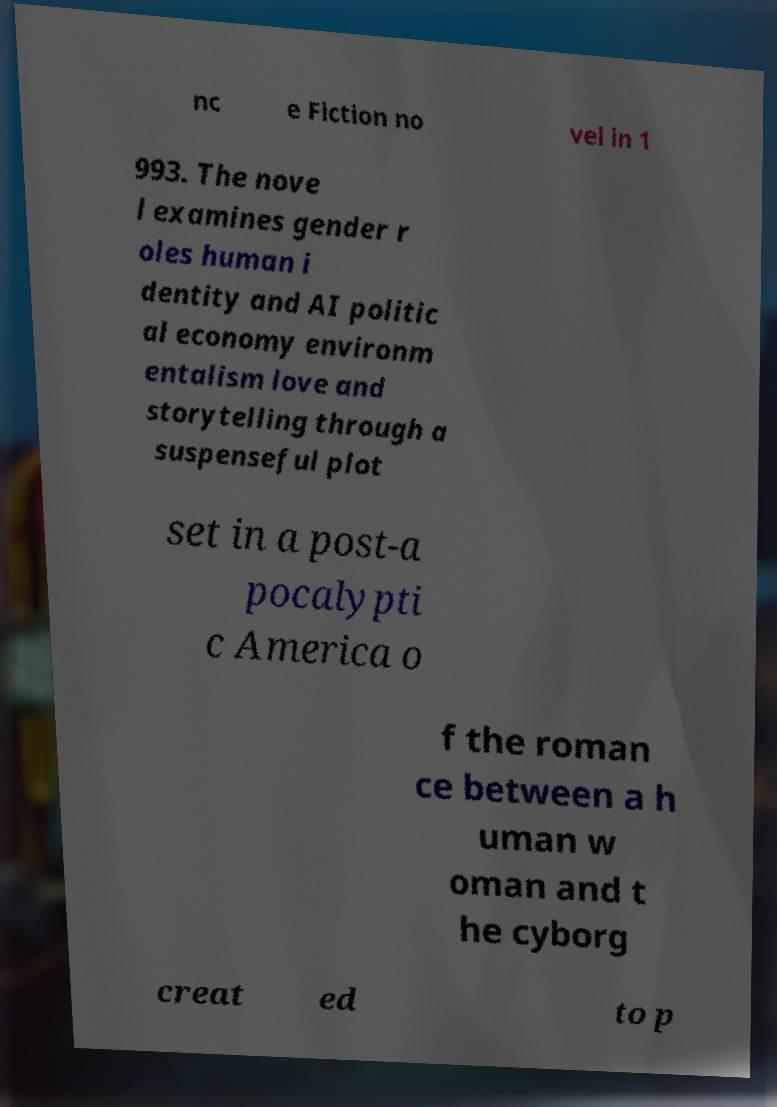What messages or text are displayed in this image? I need them in a readable, typed format. nc e Fiction no vel in 1 993. The nove l examines gender r oles human i dentity and AI politic al economy environm entalism love and storytelling through a suspenseful plot set in a post-a pocalypti c America o f the roman ce between a h uman w oman and t he cyborg creat ed to p 